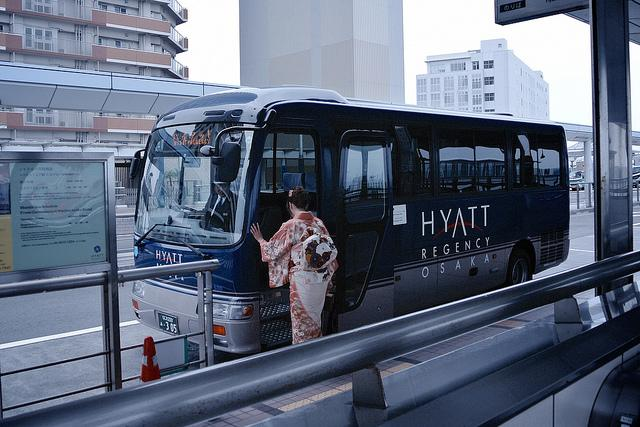In what city is this woman boarding the bus?

Choices:
A) kyoto
B) osaka
C) kobe
D) tokyo osaka 